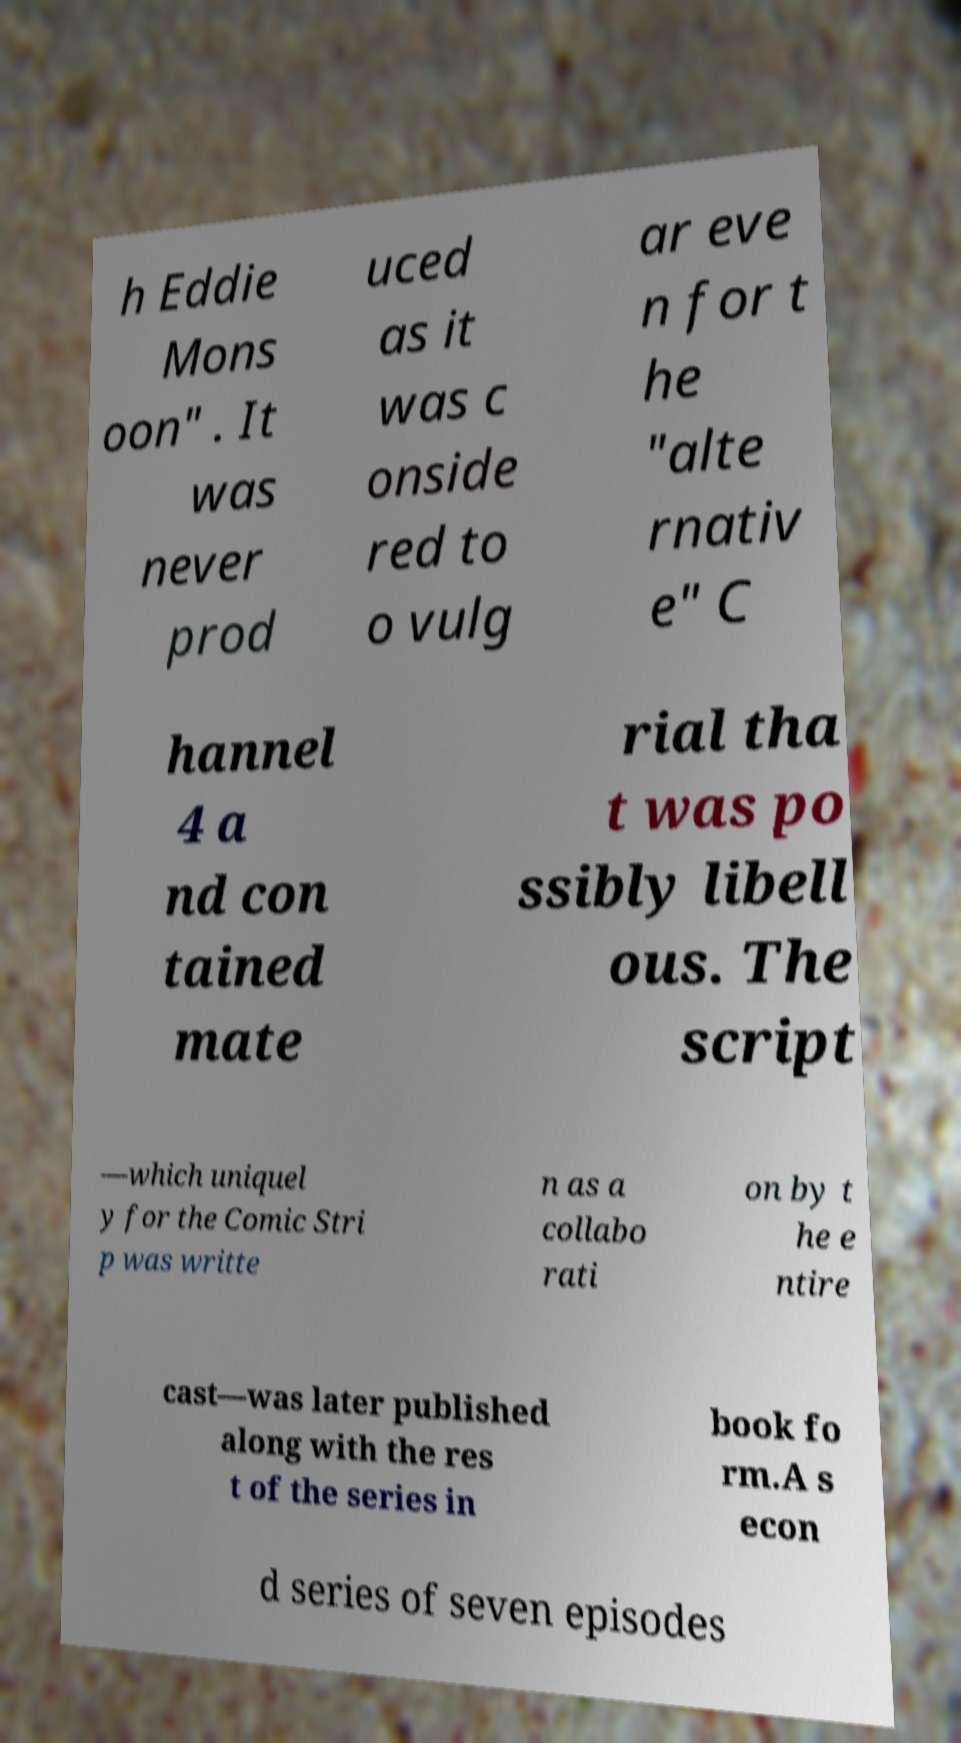I need the written content from this picture converted into text. Can you do that? h Eddie Mons oon" . It was never prod uced as it was c onside red to o vulg ar eve n for t he "alte rnativ e" C hannel 4 a nd con tained mate rial tha t was po ssibly libell ous. The script —which uniquel y for the Comic Stri p was writte n as a collabo rati on by t he e ntire cast—was later published along with the res t of the series in book fo rm.A s econ d series of seven episodes 